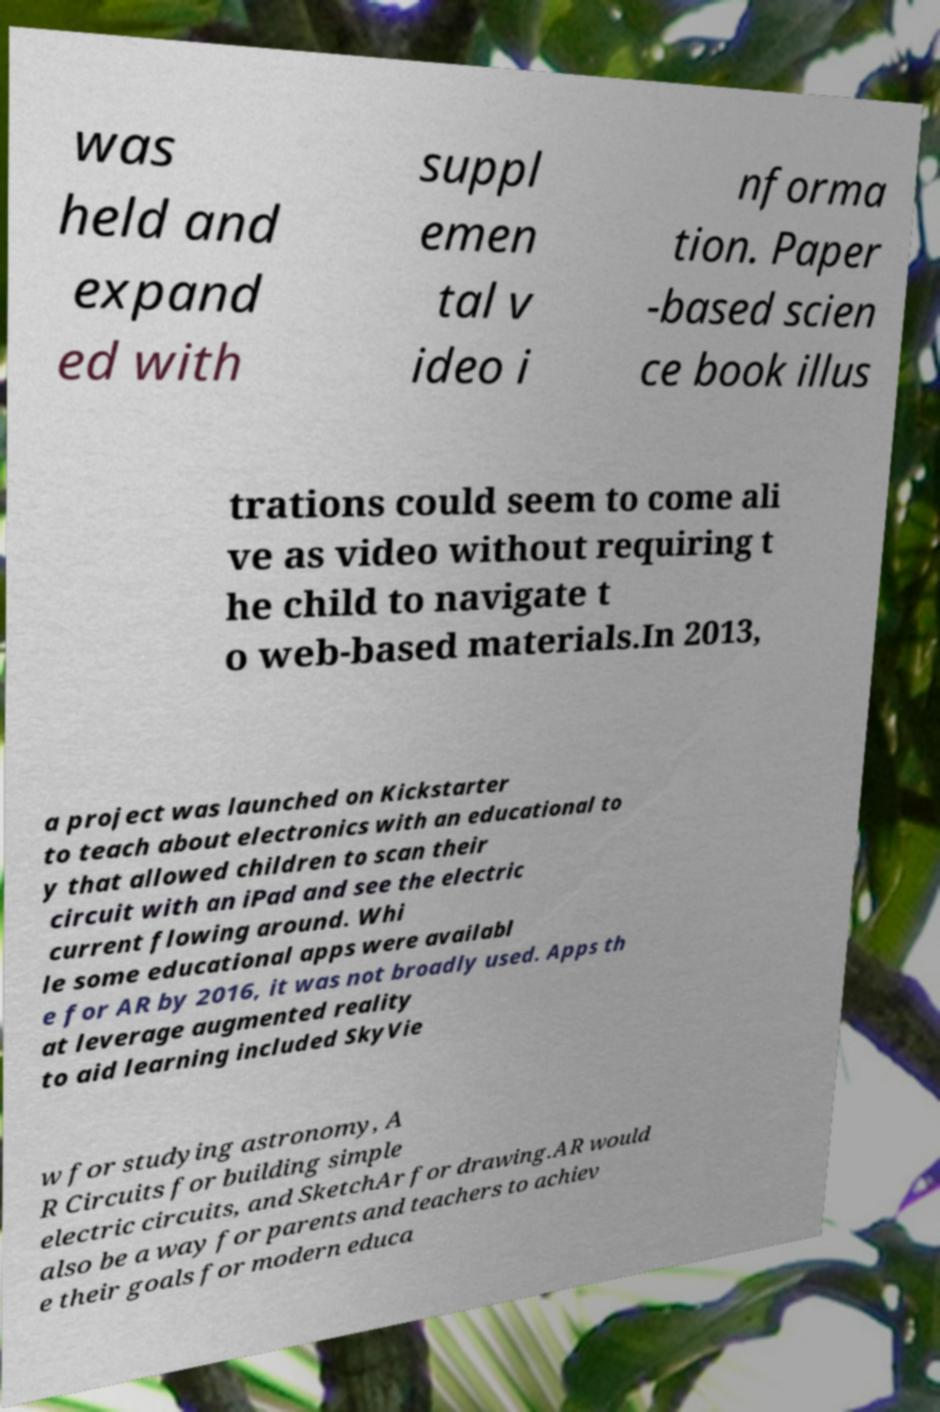I need the written content from this picture converted into text. Can you do that? was held and expand ed with suppl emen tal v ideo i nforma tion. Paper -based scien ce book illus trations could seem to come ali ve as video without requiring t he child to navigate t o web-based materials.In 2013, a project was launched on Kickstarter to teach about electronics with an educational to y that allowed children to scan their circuit with an iPad and see the electric current flowing around. Whi le some educational apps were availabl e for AR by 2016, it was not broadly used. Apps th at leverage augmented reality to aid learning included SkyVie w for studying astronomy, A R Circuits for building simple electric circuits, and SketchAr for drawing.AR would also be a way for parents and teachers to achiev e their goals for modern educa 